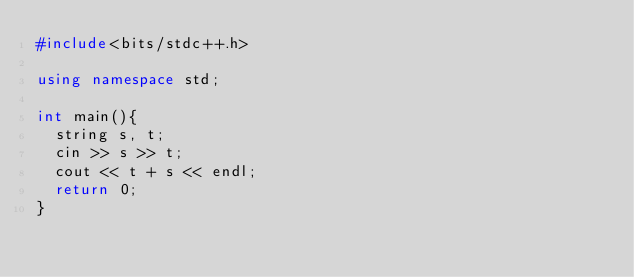<code> <loc_0><loc_0><loc_500><loc_500><_C++_>#include<bits/stdc++.h>

using namespace std;

int main(){
  string s, t;
  cin >> s >> t;
  cout << t + s << endl;
  return 0;
}</code> 